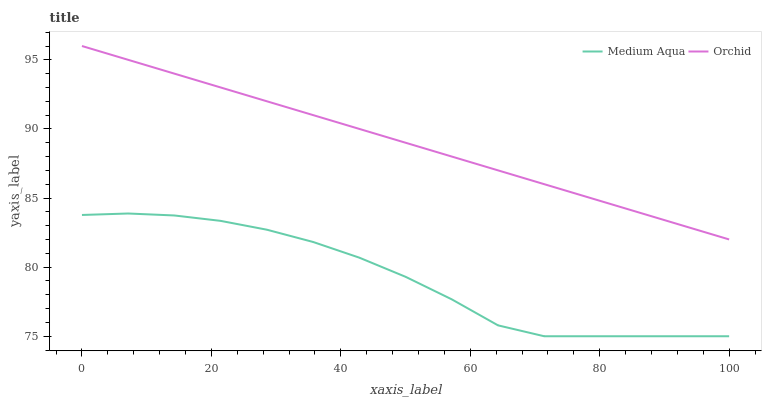Does Medium Aqua have the minimum area under the curve?
Answer yes or no. Yes. Does Orchid have the maximum area under the curve?
Answer yes or no. Yes. Does Orchid have the minimum area under the curve?
Answer yes or no. No. Is Orchid the smoothest?
Answer yes or no. Yes. Is Medium Aqua the roughest?
Answer yes or no. Yes. Is Orchid the roughest?
Answer yes or no. No. Does Medium Aqua have the lowest value?
Answer yes or no. Yes. Does Orchid have the lowest value?
Answer yes or no. No. Does Orchid have the highest value?
Answer yes or no. Yes. Is Medium Aqua less than Orchid?
Answer yes or no. Yes. Is Orchid greater than Medium Aqua?
Answer yes or no. Yes. Does Medium Aqua intersect Orchid?
Answer yes or no. No. 